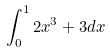<formula> <loc_0><loc_0><loc_500><loc_500>\int _ { 0 } ^ { 1 } 2 x ^ { 3 } + 3 d x</formula> 